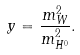<formula> <loc_0><loc_0><loc_500><loc_500>y = \frac { m _ { W } ^ { 2 } } { m _ { H ^ { 0 } } ^ { 2 } } .</formula> 